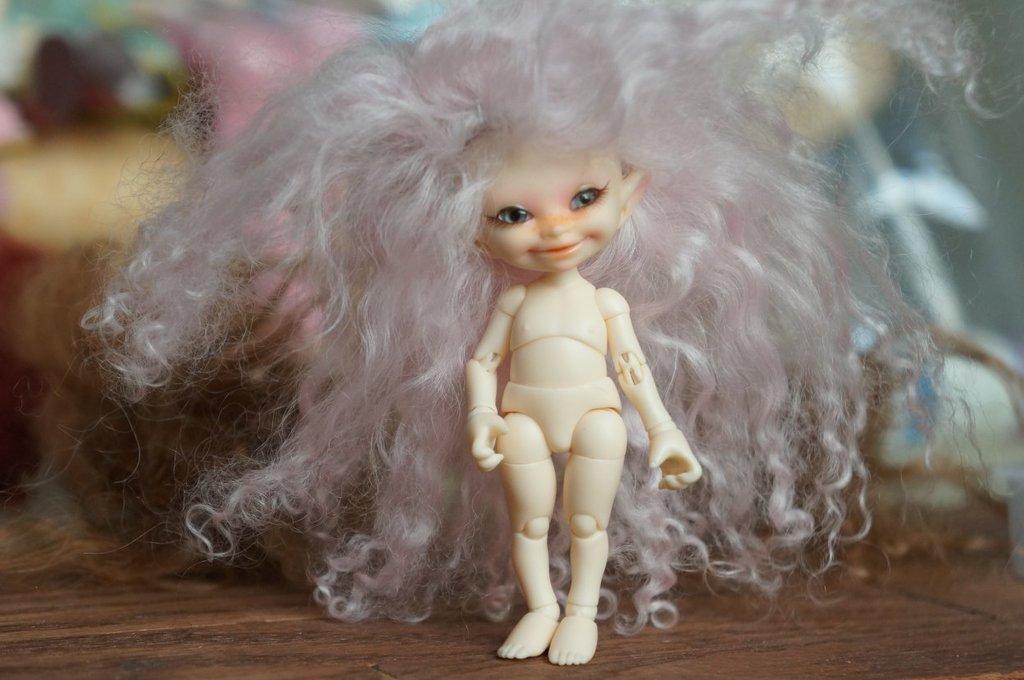Please provide a concise description of this image. In this image I can see a white color doll and pink and white color hair. The doll is on the brown color table. Background is blurred. 